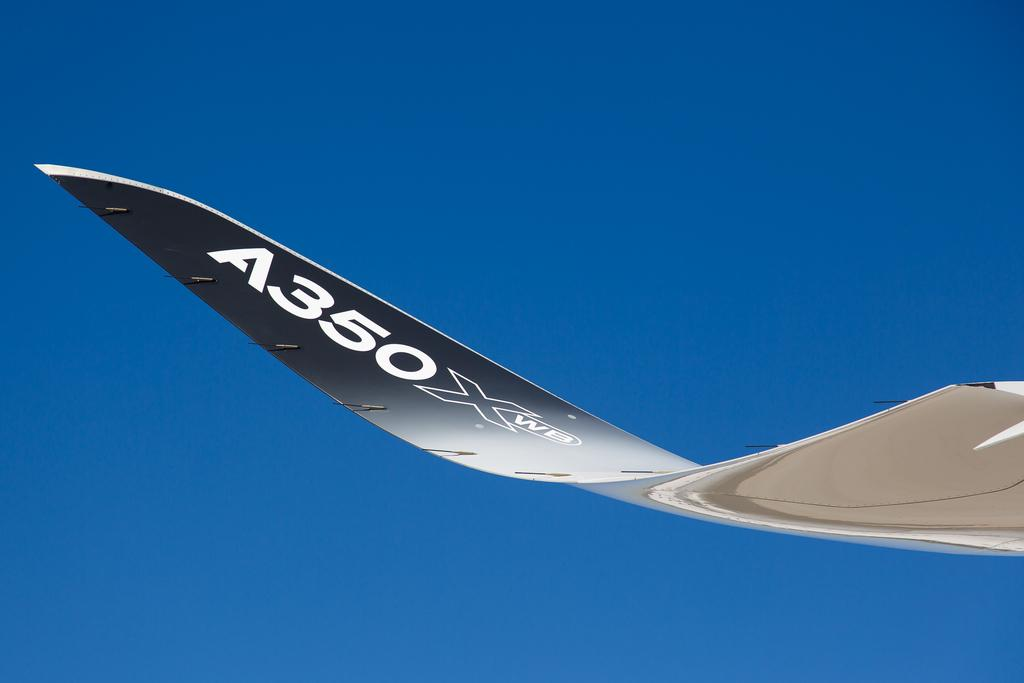<image>
Relay a brief, clear account of the picture shown. The number on the plane wing is A350 